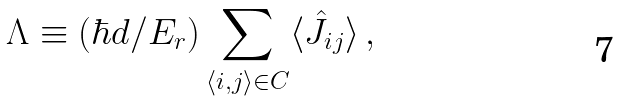Convert formula to latex. <formula><loc_0><loc_0><loc_500><loc_500>\Lambda \equiv ( \hbar { d } / E _ { r } ) \sum _ { \langle i , j \rangle \in C } \langle \hat { J } _ { i j } \rangle \, ,</formula> 